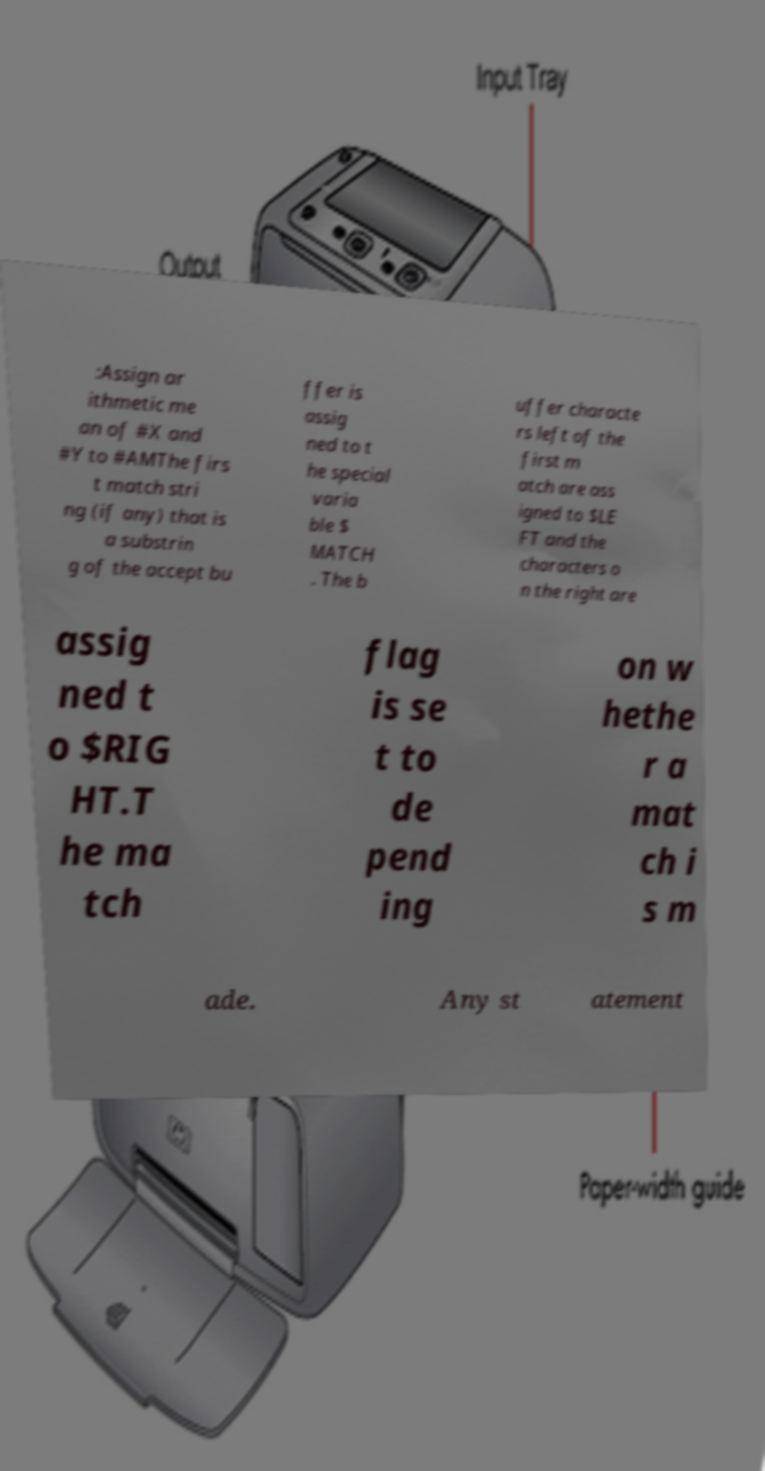Can you read and provide the text displayed in the image?This photo seems to have some interesting text. Can you extract and type it out for me? :Assign ar ithmetic me an of #X and #Y to #AMThe firs t match stri ng (if any) that is a substrin g of the accept bu ffer is assig ned to t he special varia ble $ MATCH . The b uffer characte rs left of the first m atch are ass igned to $LE FT and the characters o n the right are assig ned t o $RIG HT.T he ma tch flag is se t to de pend ing on w hethe r a mat ch i s m ade. Any st atement 